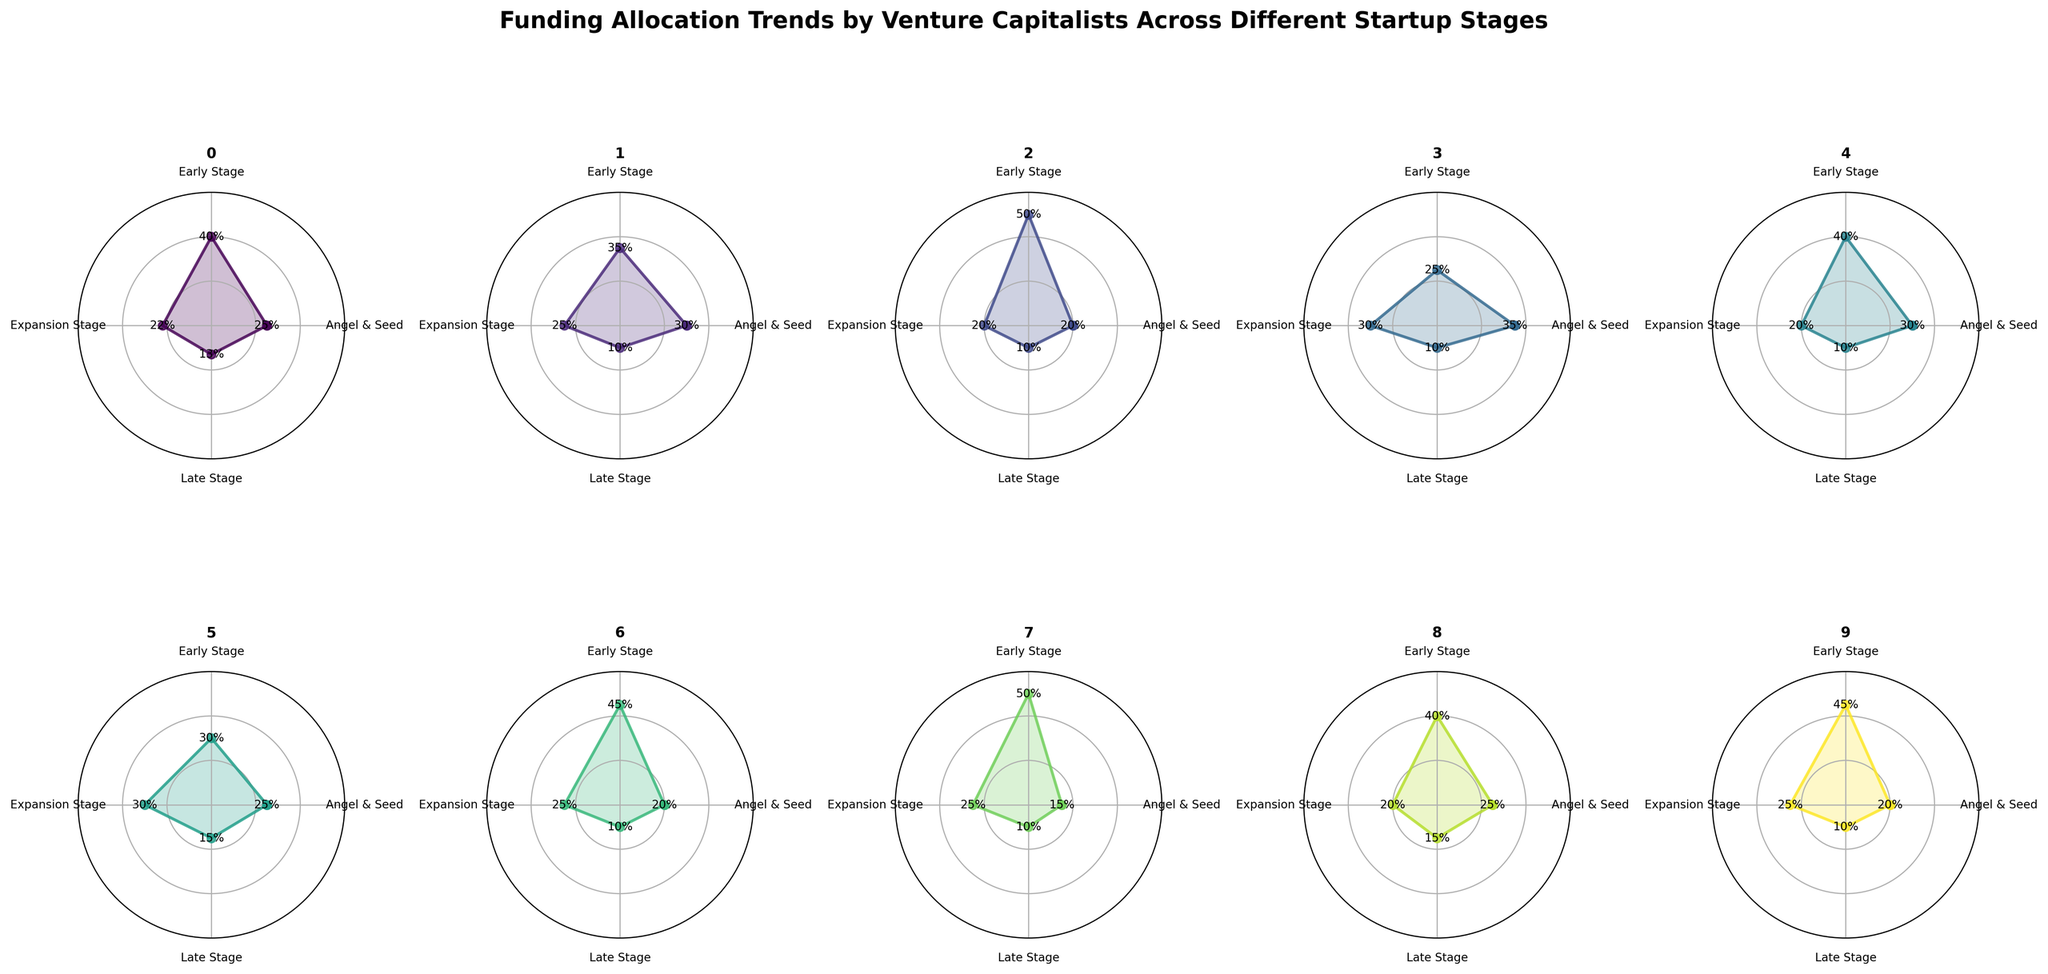Which sector has the highest allocation in the Angel & Seed stage? Looking at the Angel & Seed portion of the rose plots, E-commerce has the highest allocation with 35%.
Answer: E-commerce Which sector has the lowest allocation in the Early Stage? By observing the Early Stage segment of each rose plot, the Blockchain sector has the lowest allocation with 15%.
Answer: Blockchain What is the average funding allocation across all stages for FinTech? FinTech has allocations of 25%, 40%, 22%, and 13% in Angel & Seed, Early Stage, Expansion Stage, and Late Stage, respectively. The average is (25 + 40 + 22 + 13) / 4 = 25%.
Answer: 25% Which two sectors have exactly the same funding allocation at the Late Stage? Examining the Late Stage segments, FinTech, HealthTech, EdTech, E-commerce, AI & Machine Learning, CleanTech, Blockchain, and Agritech all have 10% allocations.
Answer: FinTech, HealthTech Is the allocation for Expansion Stage higher in Biotech or Cybersecurity? Comparing the Expansion Stage segments, both Biotech and Cybersecurity have a 20% allocation.
Answer: Equal How much more funding does CleanTech receive in the Early Stage compared to the Expansion Stage? CleanTech receives 45% in the Early Stage and 25% in the Expansion Stage. The difference is 45% - 25% = 20%.
Answer: 20% What is the total allocation percentage for the Angel & Seed stage across all sectors? Summing the Angel & Seed allocations, we get 25 + 30 + 20 + 35 + 30 + 25 + 20 + 15 + 25 + 20 = 245%.
Answer: 245% Which sector's funding allocation remains the most consistent across all stages? HealthTech remains fairly consistent with allocations of 30%, 35%, 25%, and 10% across the stages, showing the least deviation.
Answer: HealthTech What is the median allocation percentage for the Early Stage across all sectors? Sorting the Early Stage percentages [25%, 30%, 35%, 40%, 40%, 40%, 45%, 45%, 50%, 50%], the median is between the 5th and 6th items: (40 + 40) / 2 = 40%.
Answer: 40% In which sector does the Expansion Stage receive exactly half of the Angel & Seed stage funding? The EdTech sector has 20% funding in both the Angel & Seed and Expansion stages, exactly half.
Answer: EdTech 